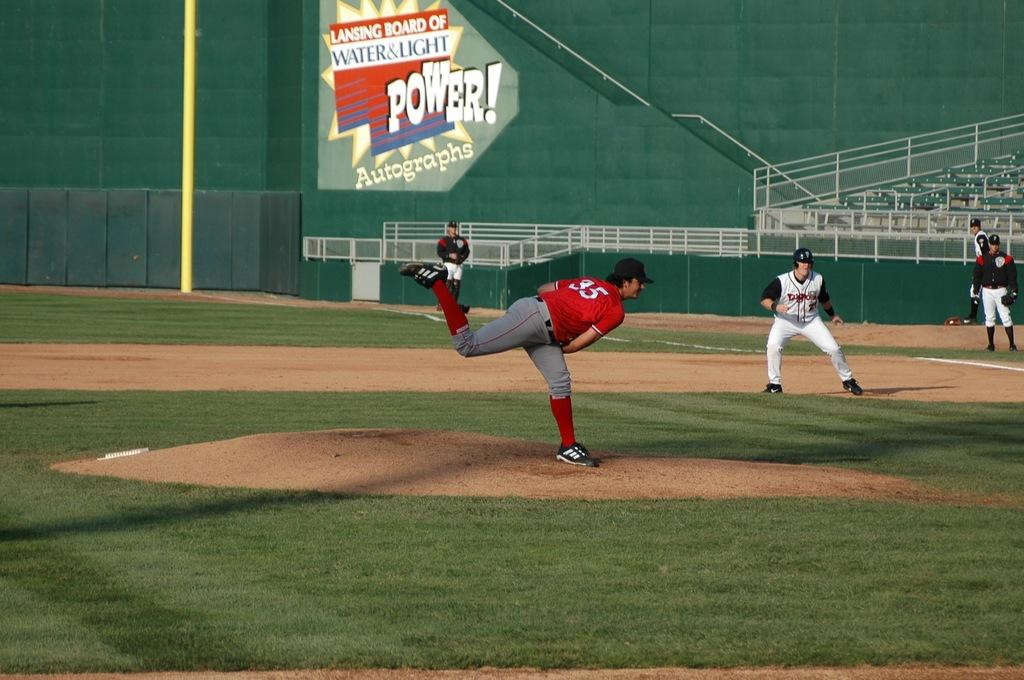<image>
Share a concise interpretation of the image provided. In a ballpark, an advertisement for the Lansing Board of Water & Light is displayed. 